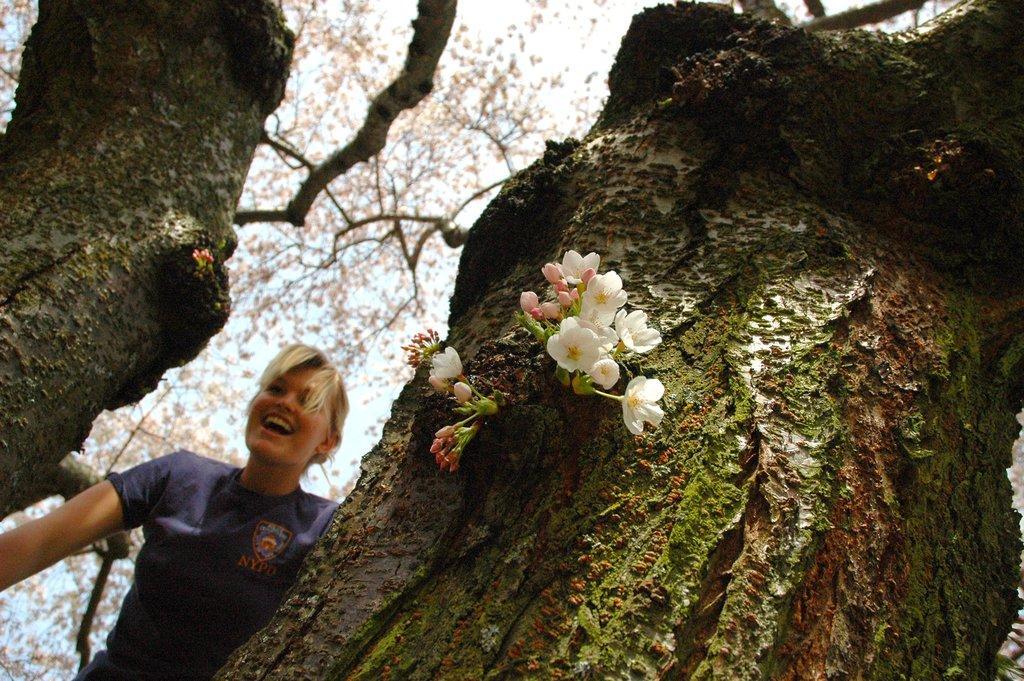Could you give a brief overview of what you see in this image? In this picture there is a person standing behind the tree and smiling. In the foreground there are flowers on the tree. At the top there is sky. 